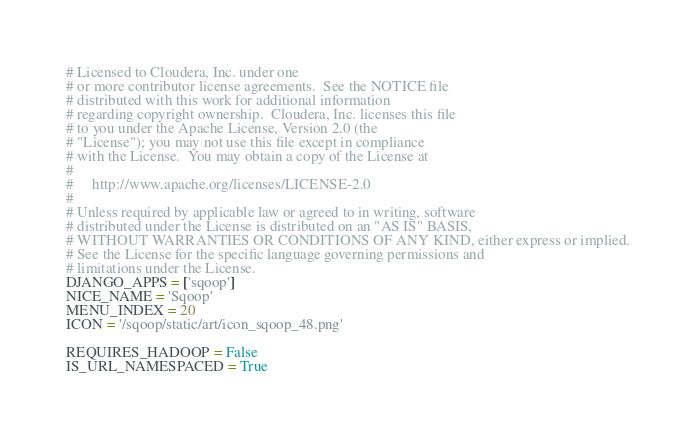Convert code to text. <code><loc_0><loc_0><loc_500><loc_500><_Python_># Licensed to Cloudera, Inc. under one
# or more contributor license agreements.  See the NOTICE file
# distributed with this work for additional information
# regarding copyright ownership.  Cloudera, Inc. licenses this file
# to you under the Apache License, Version 2.0 (the
# "License"); you may not use this file except in compliance
# with the License.  You may obtain a copy of the License at
#
#     http://www.apache.org/licenses/LICENSE-2.0
#
# Unless required by applicable law or agreed to in writing, software
# distributed under the License is distributed on an "AS IS" BASIS,
# WITHOUT WARRANTIES OR CONDITIONS OF ANY KIND, either express or implied.
# See the License for the specific language governing permissions and
# limitations under the License.
DJANGO_APPS = ['sqoop']
NICE_NAME = 'Sqoop'
MENU_INDEX = 20
ICON = '/sqoop/static/art/icon_sqoop_48.png'

REQUIRES_HADOOP = False
IS_URL_NAMESPACED = True
</code> 